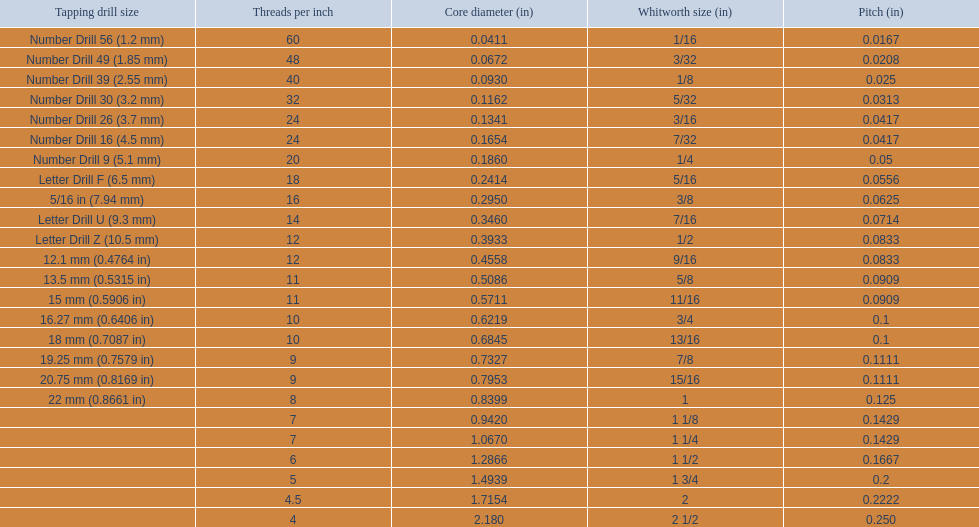What are all of the whitworth sizes in the british standard whitworth? 1/16, 3/32, 1/8, 5/32, 3/16, 7/32, 1/4, 5/16, 3/8, 7/16, 1/2, 9/16, 5/8, 11/16, 3/4, 13/16, 7/8, 15/16, 1, 1 1/8, 1 1/4, 1 1/2, 1 3/4, 2, 2 1/2. Which of these sizes uses a tapping drill size of 26? 3/16. 